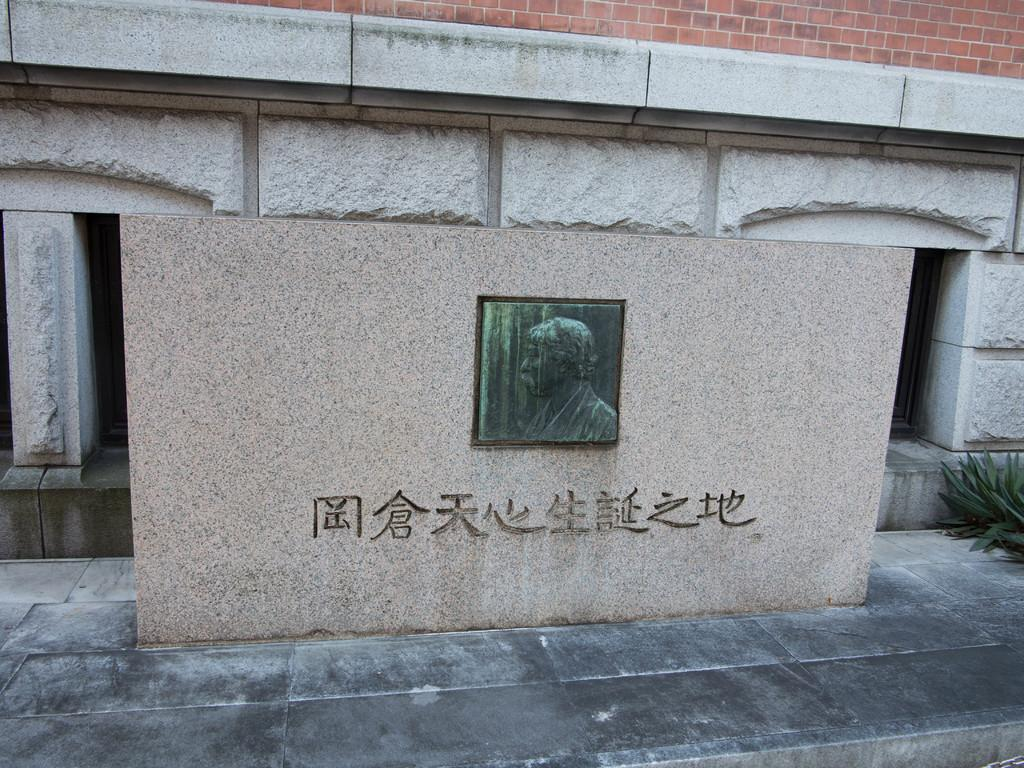What type of structure is present in the image? There is a building in the image. What colors can be seen on the building? The building has gray and brown colors. What is attached to the wall in the image? There is a frame attached to the wall in the image. What type of vegetation is present in the image? There are plants in the image. What color are the plants? The plants have green color. How many boats can be seen in the image? There are no boats present in the image. What type of jar is placed on the table in the image? There is no jar present in the image. 